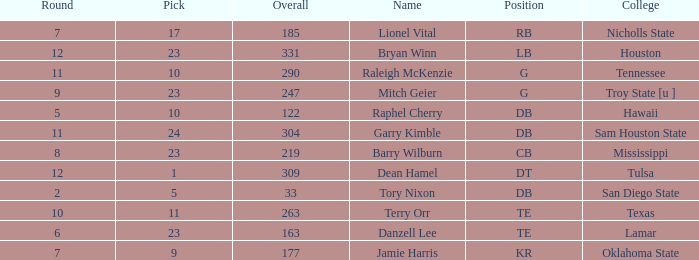How many Picks have a College of hawaii, and an Overall smaller than 122? 0.0. 